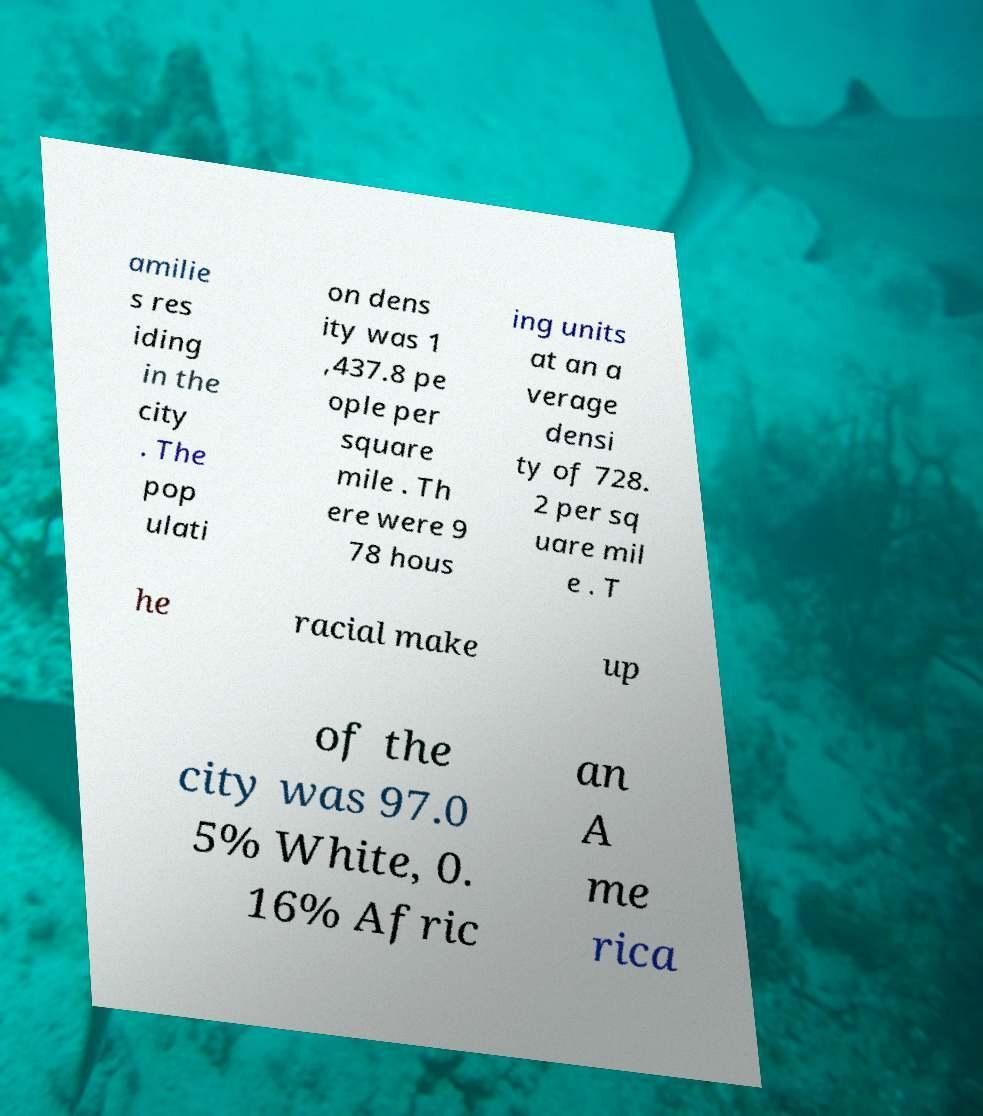For documentation purposes, I need the text within this image transcribed. Could you provide that? amilie s res iding in the city . The pop ulati on dens ity was 1 ,437.8 pe ople per square mile . Th ere were 9 78 hous ing units at an a verage densi ty of 728. 2 per sq uare mil e . T he racial make up of the city was 97.0 5% White, 0. 16% Afric an A me rica 